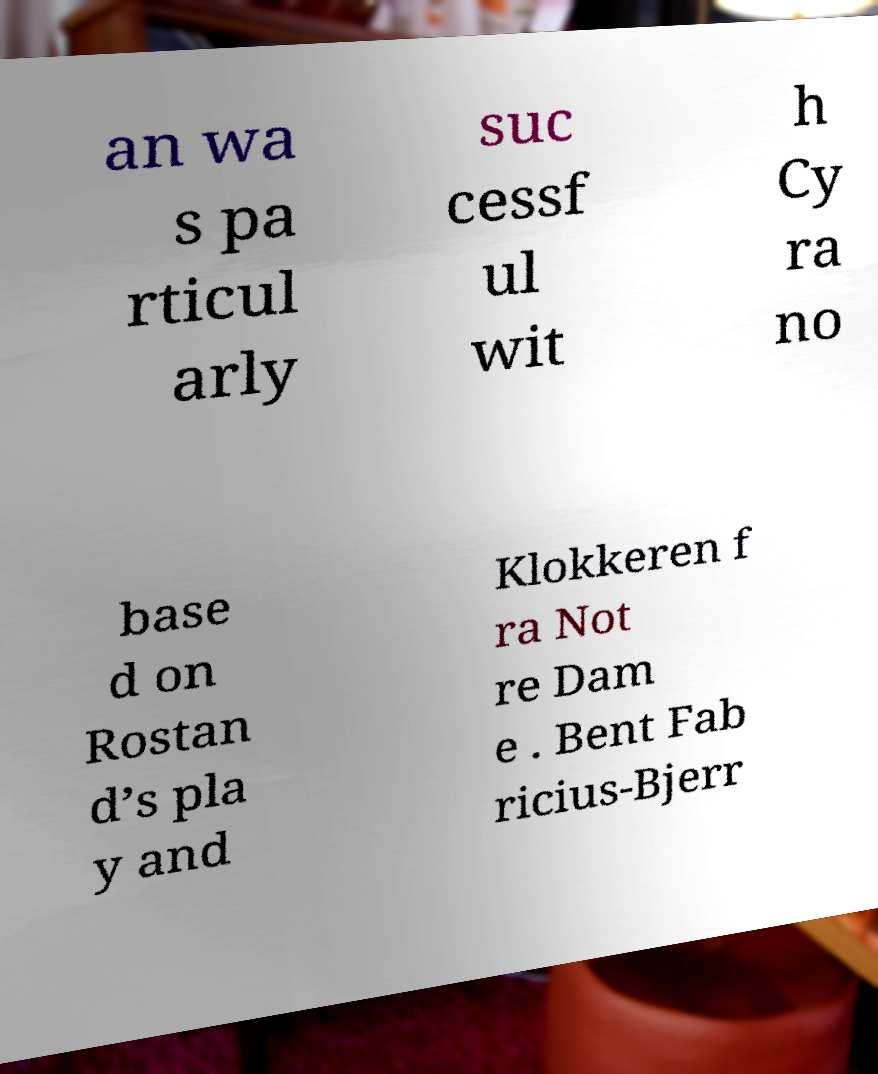There's text embedded in this image that I need extracted. Can you transcribe it verbatim? an wa s pa rticul arly suc cessf ul wit h Cy ra no base d on Rostan d’s pla y and Klokkeren f ra Not re Dam e . Bent Fab ricius-Bjerr 